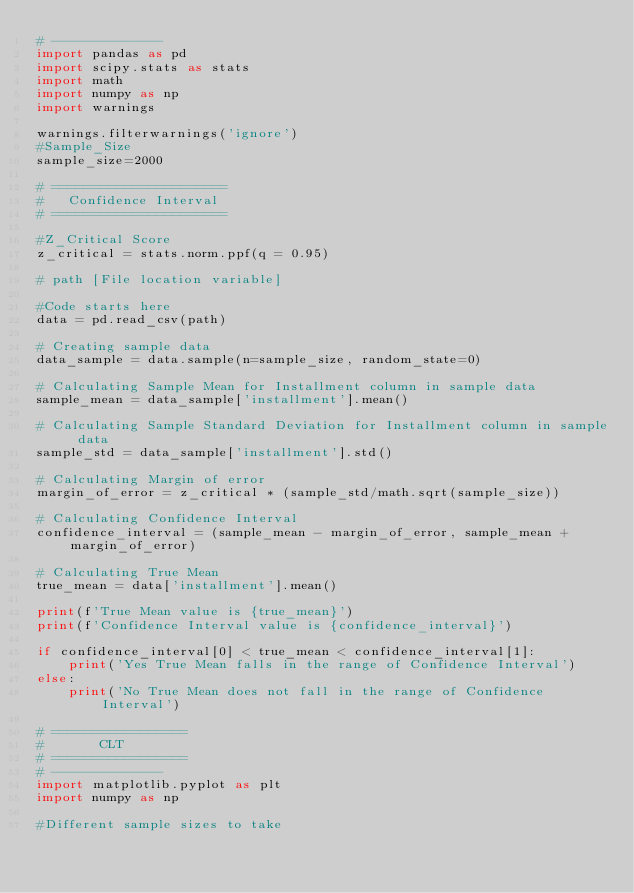Convert code to text. <code><loc_0><loc_0><loc_500><loc_500><_Python_># --------------
import pandas as pd
import scipy.stats as stats
import math
import numpy as np
import warnings

warnings.filterwarnings('ignore')
#Sample_Size
sample_size=2000

# ======================
#   Confidence Interval
# ======================

#Z_Critical Score
z_critical = stats.norm.ppf(q = 0.95)  

# path [File location variable]

#Code starts here
data = pd.read_csv(path)

# Creating sample data 
data_sample = data.sample(n=sample_size, random_state=0)

# Calculating Sample Mean for Installment column in sample data 
sample_mean = data_sample['installment'].mean()

# Calculating Sample Standard Deviation for Installment column in sample data 
sample_std = data_sample['installment'].std() 

# Calculating Margin of error 
margin_of_error = z_critical * (sample_std/math.sqrt(sample_size)) 

# Calculating Confidence Interval
confidence_interval = (sample_mean - margin_of_error, sample_mean + margin_of_error)

# Calculating True Mean 
true_mean = data['installment'].mean() 

print(f'True Mean value is {true_mean}')
print(f'Confidence Interval value is {confidence_interval}')

if confidence_interval[0] < true_mean < confidence_interval[1]:
    print('Yes True Mean falls in the range of Confidence Interval')
else:
    print('No True Mean does not fall in the range of Confidence Interval') 

# =================
#       CLT
# =================
# --------------
import matplotlib.pyplot as plt
import numpy as np

#Different sample sizes to take</code> 